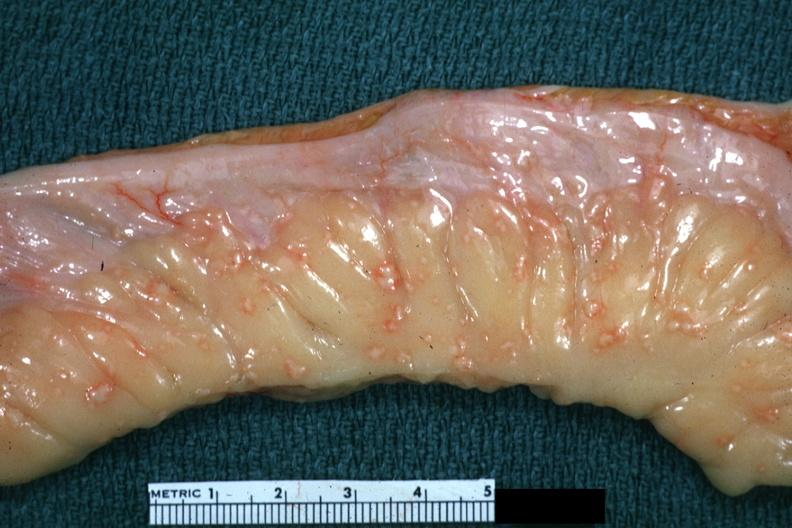does this image show rather close-up excellent depiction of lesions of tuberculous peritonitis?
Answer the question using a single word or phrase. Yes 